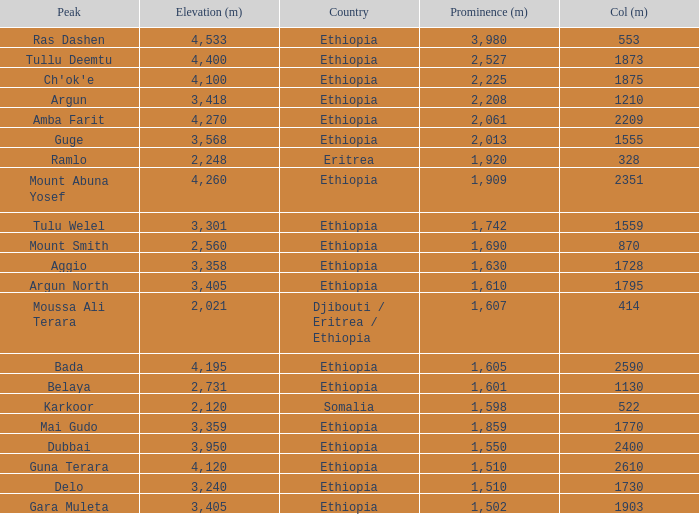What is the sum of the prominence in m of moussa ali terara peak? 1607.0. 